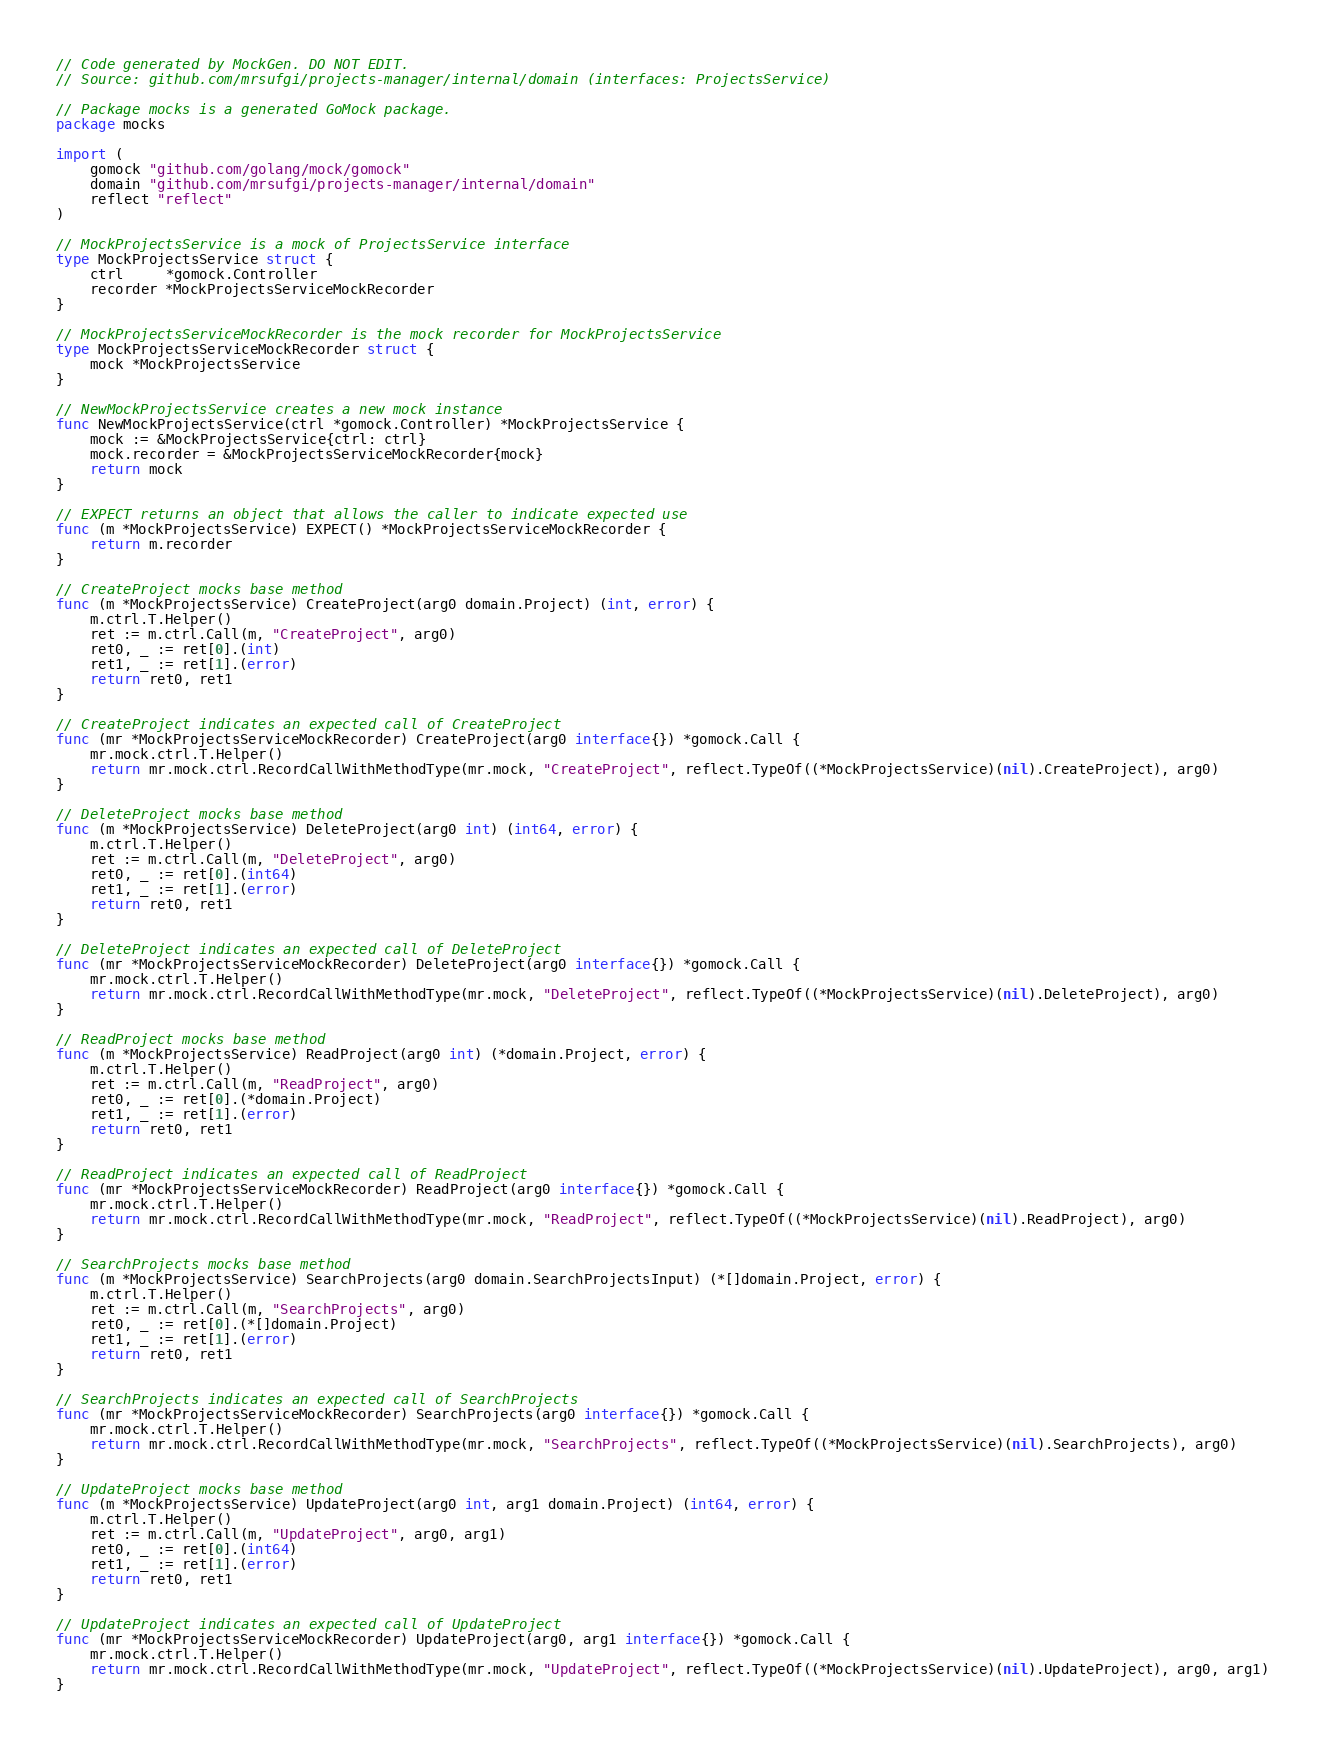Convert code to text. <code><loc_0><loc_0><loc_500><loc_500><_Go_>// Code generated by MockGen. DO NOT EDIT.
// Source: github.com/mrsufgi/projects-manager/internal/domain (interfaces: ProjectsService)

// Package mocks is a generated GoMock package.
package mocks

import (
	gomock "github.com/golang/mock/gomock"
	domain "github.com/mrsufgi/projects-manager/internal/domain"
	reflect "reflect"
)

// MockProjectsService is a mock of ProjectsService interface
type MockProjectsService struct {
	ctrl     *gomock.Controller
	recorder *MockProjectsServiceMockRecorder
}

// MockProjectsServiceMockRecorder is the mock recorder for MockProjectsService
type MockProjectsServiceMockRecorder struct {
	mock *MockProjectsService
}

// NewMockProjectsService creates a new mock instance
func NewMockProjectsService(ctrl *gomock.Controller) *MockProjectsService {
	mock := &MockProjectsService{ctrl: ctrl}
	mock.recorder = &MockProjectsServiceMockRecorder{mock}
	return mock
}

// EXPECT returns an object that allows the caller to indicate expected use
func (m *MockProjectsService) EXPECT() *MockProjectsServiceMockRecorder {
	return m.recorder
}

// CreateProject mocks base method
func (m *MockProjectsService) CreateProject(arg0 domain.Project) (int, error) {
	m.ctrl.T.Helper()
	ret := m.ctrl.Call(m, "CreateProject", arg0)
	ret0, _ := ret[0].(int)
	ret1, _ := ret[1].(error)
	return ret0, ret1
}

// CreateProject indicates an expected call of CreateProject
func (mr *MockProjectsServiceMockRecorder) CreateProject(arg0 interface{}) *gomock.Call {
	mr.mock.ctrl.T.Helper()
	return mr.mock.ctrl.RecordCallWithMethodType(mr.mock, "CreateProject", reflect.TypeOf((*MockProjectsService)(nil).CreateProject), arg0)
}

// DeleteProject mocks base method
func (m *MockProjectsService) DeleteProject(arg0 int) (int64, error) {
	m.ctrl.T.Helper()
	ret := m.ctrl.Call(m, "DeleteProject", arg0)
	ret0, _ := ret[0].(int64)
	ret1, _ := ret[1].(error)
	return ret0, ret1
}

// DeleteProject indicates an expected call of DeleteProject
func (mr *MockProjectsServiceMockRecorder) DeleteProject(arg0 interface{}) *gomock.Call {
	mr.mock.ctrl.T.Helper()
	return mr.mock.ctrl.RecordCallWithMethodType(mr.mock, "DeleteProject", reflect.TypeOf((*MockProjectsService)(nil).DeleteProject), arg0)
}

// ReadProject mocks base method
func (m *MockProjectsService) ReadProject(arg0 int) (*domain.Project, error) {
	m.ctrl.T.Helper()
	ret := m.ctrl.Call(m, "ReadProject", arg0)
	ret0, _ := ret[0].(*domain.Project)
	ret1, _ := ret[1].(error)
	return ret0, ret1
}

// ReadProject indicates an expected call of ReadProject
func (mr *MockProjectsServiceMockRecorder) ReadProject(arg0 interface{}) *gomock.Call {
	mr.mock.ctrl.T.Helper()
	return mr.mock.ctrl.RecordCallWithMethodType(mr.mock, "ReadProject", reflect.TypeOf((*MockProjectsService)(nil).ReadProject), arg0)
}

// SearchProjects mocks base method
func (m *MockProjectsService) SearchProjects(arg0 domain.SearchProjectsInput) (*[]domain.Project, error) {
	m.ctrl.T.Helper()
	ret := m.ctrl.Call(m, "SearchProjects", arg0)
	ret0, _ := ret[0].(*[]domain.Project)
	ret1, _ := ret[1].(error)
	return ret0, ret1
}

// SearchProjects indicates an expected call of SearchProjects
func (mr *MockProjectsServiceMockRecorder) SearchProjects(arg0 interface{}) *gomock.Call {
	mr.mock.ctrl.T.Helper()
	return mr.mock.ctrl.RecordCallWithMethodType(mr.mock, "SearchProjects", reflect.TypeOf((*MockProjectsService)(nil).SearchProjects), arg0)
}

// UpdateProject mocks base method
func (m *MockProjectsService) UpdateProject(arg0 int, arg1 domain.Project) (int64, error) {
	m.ctrl.T.Helper()
	ret := m.ctrl.Call(m, "UpdateProject", arg0, arg1)
	ret0, _ := ret[0].(int64)
	ret1, _ := ret[1].(error)
	return ret0, ret1
}

// UpdateProject indicates an expected call of UpdateProject
func (mr *MockProjectsServiceMockRecorder) UpdateProject(arg0, arg1 interface{}) *gomock.Call {
	mr.mock.ctrl.T.Helper()
	return mr.mock.ctrl.RecordCallWithMethodType(mr.mock, "UpdateProject", reflect.TypeOf((*MockProjectsService)(nil).UpdateProject), arg0, arg1)
}
</code> 